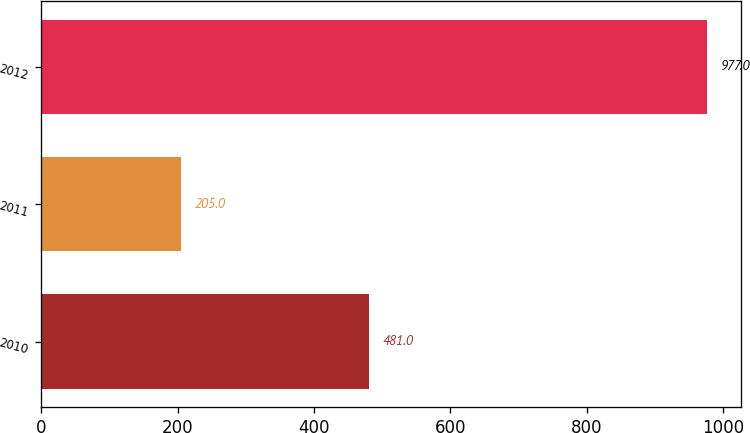<chart> <loc_0><loc_0><loc_500><loc_500><bar_chart><fcel>2010<fcel>2011<fcel>2012<nl><fcel>481<fcel>205<fcel>977<nl></chart> 